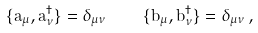<formula> <loc_0><loc_0><loc_500><loc_500>\{ a _ { \mu } , a _ { \nu } ^ { \dag } \} = \delta _ { \mu \nu } \quad \{ b _ { \mu } , b _ { \nu } ^ { \dag } \} = \delta _ { \mu \nu } \, ,</formula> 